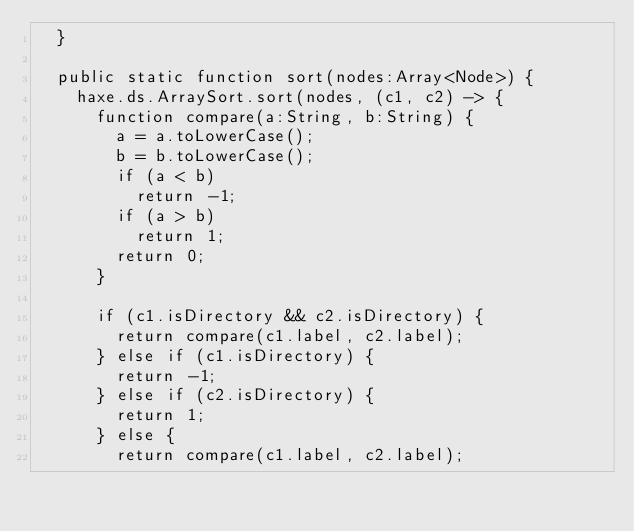<code> <loc_0><loc_0><loc_500><loc_500><_Haxe_>	}

	public static function sort(nodes:Array<Node>) {
		haxe.ds.ArraySort.sort(nodes, (c1, c2) -> {
			function compare(a:String, b:String) {
				a = a.toLowerCase();
				b = b.toLowerCase();
				if (a < b)
					return -1;
				if (a > b)
					return 1;
				return 0;
			}

			if (c1.isDirectory && c2.isDirectory) {
				return compare(c1.label, c2.label);
			} else if (c1.isDirectory) {
				return -1;
			} else if (c2.isDirectory) {
				return 1;
			} else {
				return compare(c1.label, c2.label);</code> 